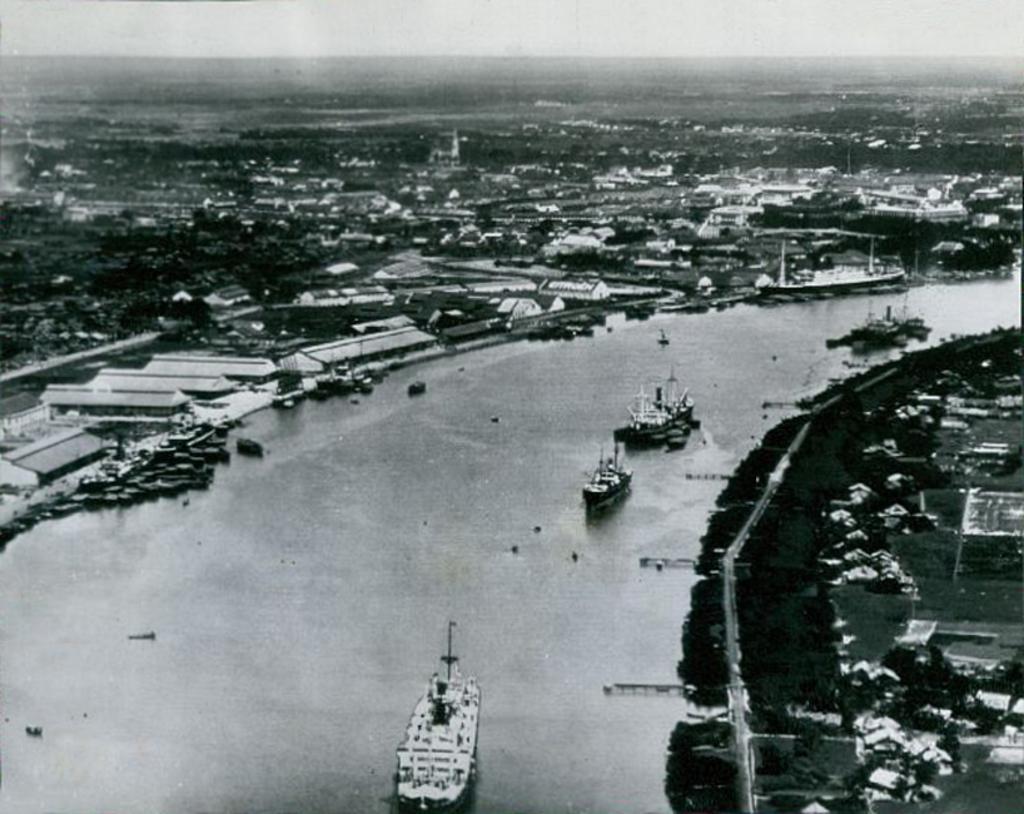Could you give a brief overview of what you see in this image? In the foreground of this black and white image, there are few ships on the water. On the right, there are few buildings and it seems like trees. In the background, there is the city and the sky. 